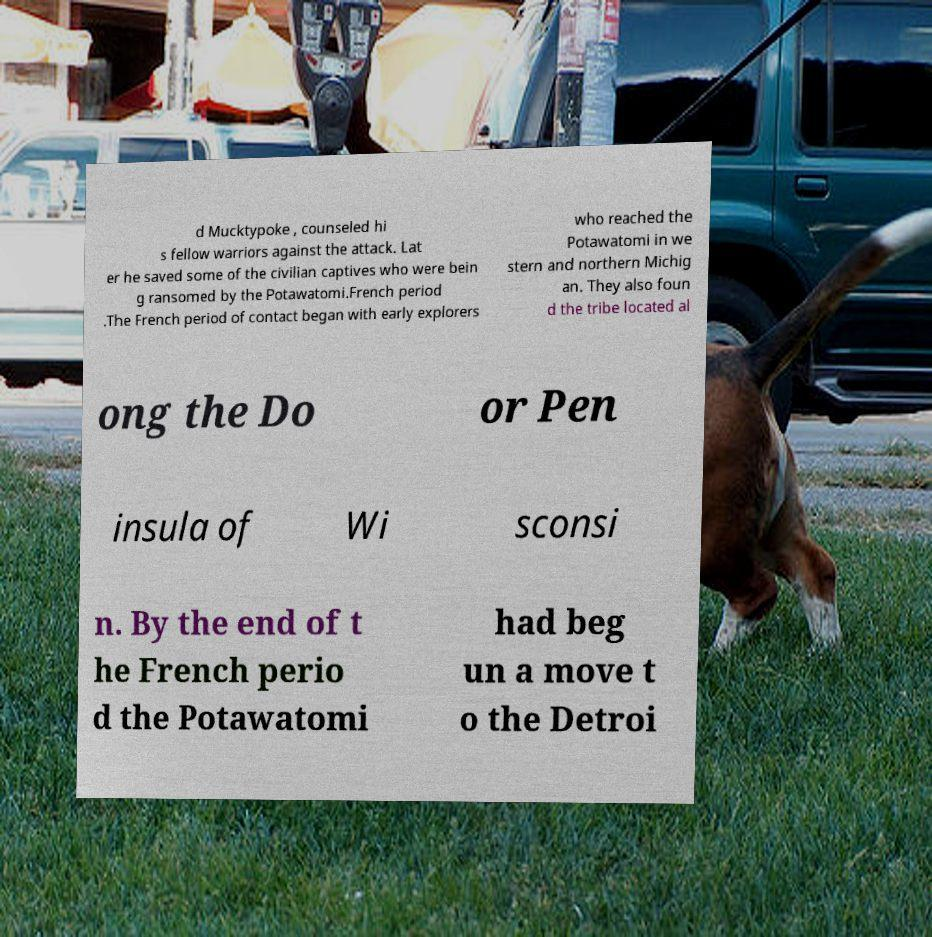Could you extract and type out the text from this image? d Mucktypoke , counseled hi s fellow warriors against the attack. Lat er he saved some of the civilian captives who were bein g ransomed by the Potawatomi.French period .The French period of contact began with early explorers who reached the Potawatomi in we stern and northern Michig an. They also foun d the tribe located al ong the Do or Pen insula of Wi sconsi n. By the end of t he French perio d the Potawatomi had beg un a move t o the Detroi 